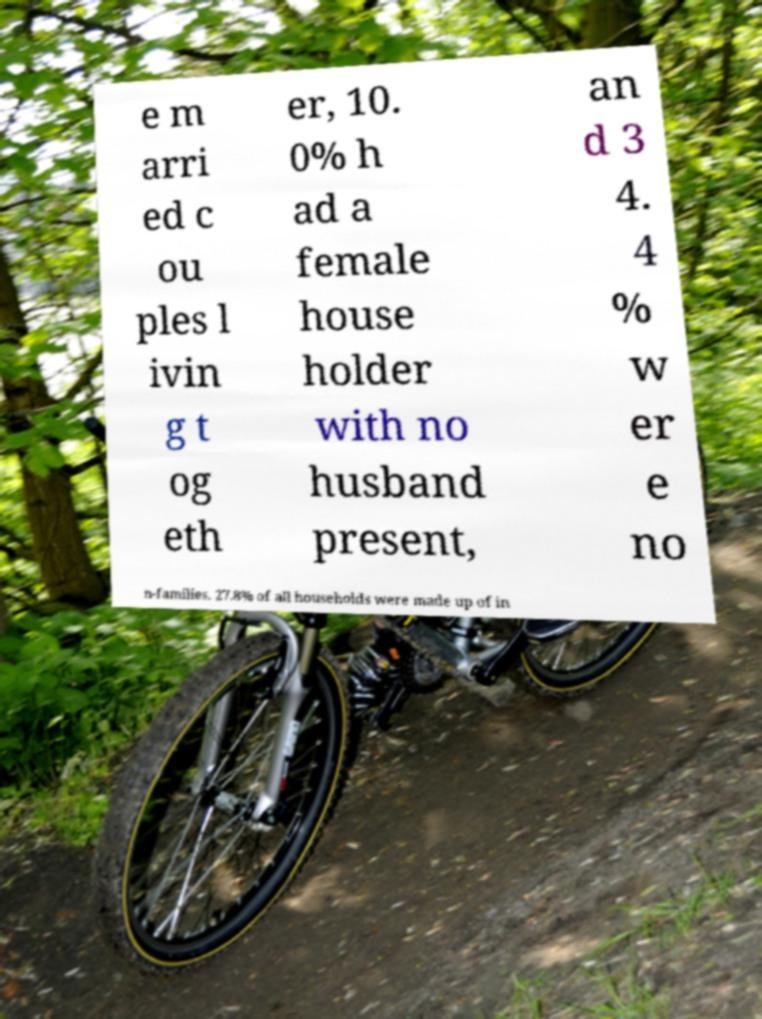I need the written content from this picture converted into text. Can you do that? e m arri ed c ou ples l ivin g t og eth er, 10. 0% h ad a female house holder with no husband present, an d 3 4. 4 % w er e no n-families. 27.8% of all households were made up of in 